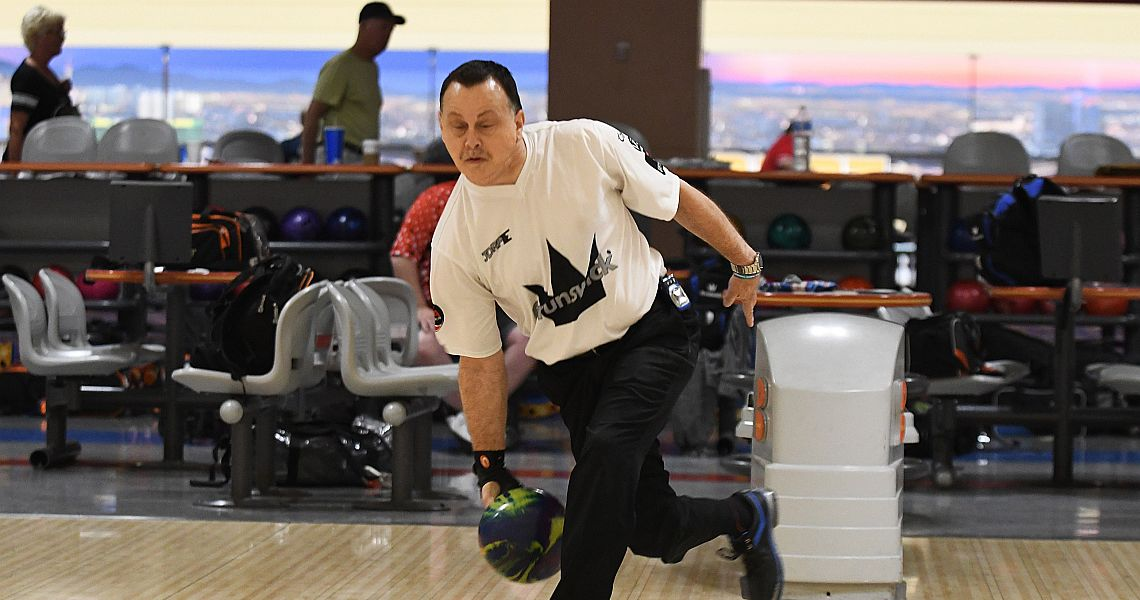How does the setting of the event contribute to the overall atmosphere and experience for the participants? The setting of the bowling alley contributes significantly to the overall atmosphere and experience for the participants. The organized, clean, and well-lit environment reflects a level of professionalism and care, enhancing the seriousness of the event. Additionally, the layout with personalized equipment storage and designated player areas fosters a sense of belonging and order. The background details, such as the cityscape view, add a layer of openness and relaxation, making the experience enjoyable and visually appealing for the participants. These elements combined create a balanced atmosphere where competition and social interaction thrive. 